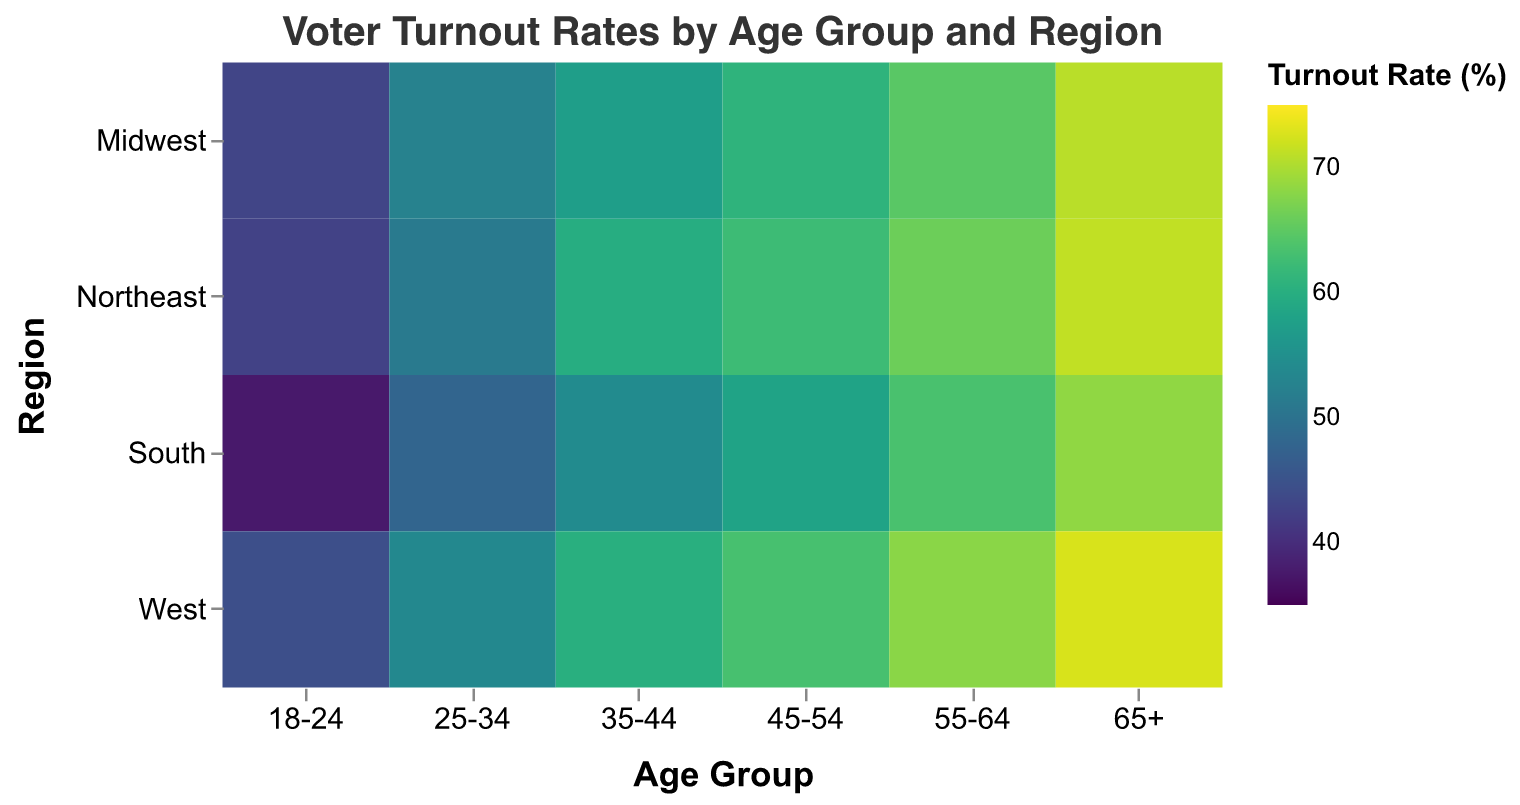What is the voter turnout rate for the age group 18-24 in the Northeast region? Look at the intersection of the "Northeast" row and the "18-24" column in the heatmap: it shows a color representation indicative of the turnout rate value.
Answer: 42.7% Which region has the highest turnout rate for the age group 25-34? Compare the turnout rates for the age group 25-34 across all regions ("Northeast", "Midwest", "South", "West") and find the highest value.
Answer: West By how much does the turnout rate for the age group 65+ in the South differ from the rate in the West? Look at the turnout rates for the age group 65+ in both the "South" and "West" regions. Subtract the South's rate from the West's rate: 72.7% - 68.4%.
Answer: 4.3% What is the average turnout rate for the age group 55-64 across all regions? Add the turnout rates for the age group 55-64 across all regions (Northeast, Midwest, South, West) and divide by the number of regions: (66.1+64.7+63.5+68)/4.
Answer: 65.6% Which age group shows the highest overall turnout rate in the Northeast region? Compare the turnout rates for all age groups in the "Northeast" row and identify the highest value.
Answer: 65+ Is the voter turnout rate for the age group 18-24 higher in the West or the Midwest? Compare the turnout rates for the age group 18-24 in the "West" and "Midwest" regions.
Answer: West Identify the region with the lowest turnout rate for the 45-54 age group. Compare the turnout rates for the age group 45-54 across all regions (Northeast, Midwest, South, West) and find the lowest value.
Answer: South What's the overall trend in turnout rate as age increases in the Northeast region? Observe the pattern of turnout rates from "18-24" to "65+" in the "Northeast" row to determine if the rate generally increases, decreases, or remains stable.
Answer: Increases 